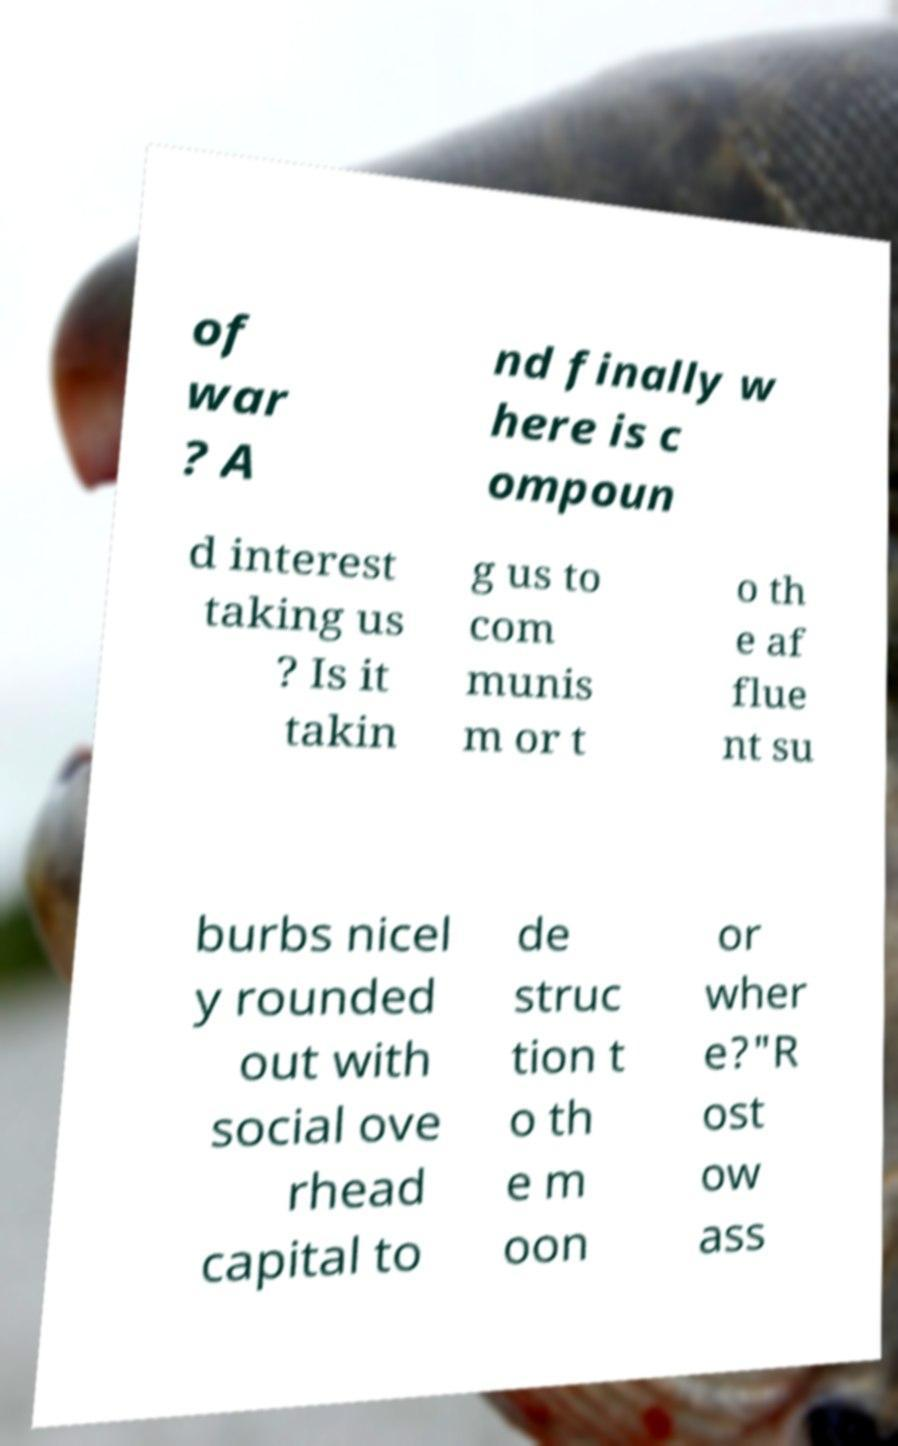Could you assist in decoding the text presented in this image and type it out clearly? of war ? A nd finally w here is c ompoun d interest taking us ? Is it takin g us to com munis m or t o th e af flue nt su burbs nicel y rounded out with social ove rhead capital to de struc tion t o th e m oon or wher e?"R ost ow ass 